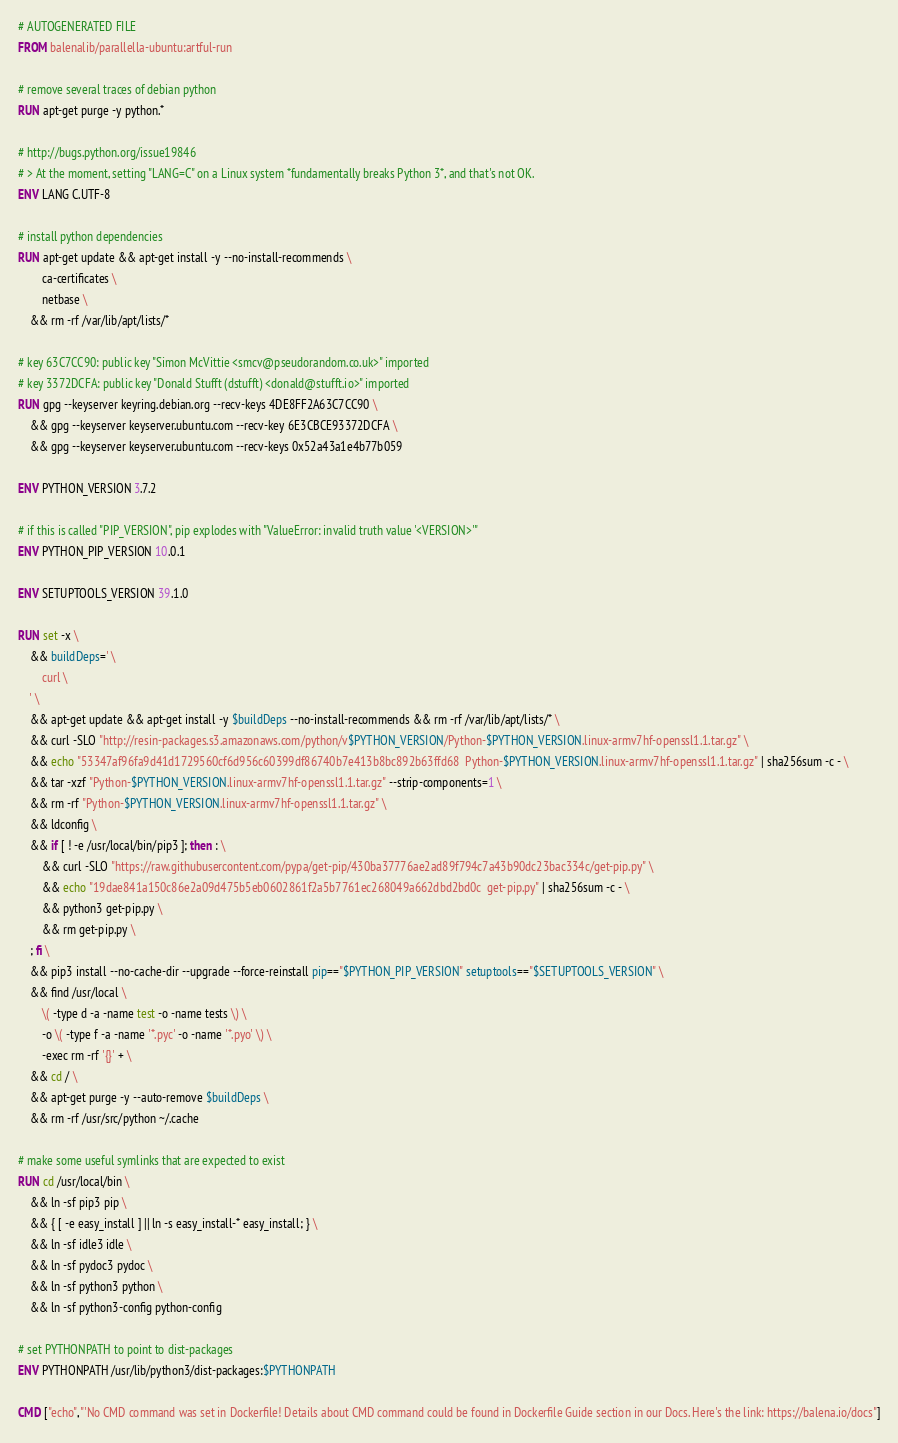<code> <loc_0><loc_0><loc_500><loc_500><_Dockerfile_># AUTOGENERATED FILE
FROM balenalib/parallella-ubuntu:artful-run

# remove several traces of debian python
RUN apt-get purge -y python.*

# http://bugs.python.org/issue19846
# > At the moment, setting "LANG=C" on a Linux system *fundamentally breaks Python 3*, and that's not OK.
ENV LANG C.UTF-8

# install python dependencies
RUN apt-get update && apt-get install -y --no-install-recommends \
		ca-certificates \
		netbase \
	&& rm -rf /var/lib/apt/lists/*

# key 63C7CC90: public key "Simon McVittie <smcv@pseudorandom.co.uk>" imported
# key 3372DCFA: public key "Donald Stufft (dstufft) <donald@stufft.io>" imported
RUN gpg --keyserver keyring.debian.org --recv-keys 4DE8FF2A63C7CC90 \
	&& gpg --keyserver keyserver.ubuntu.com --recv-key 6E3CBCE93372DCFA \
	&& gpg --keyserver keyserver.ubuntu.com --recv-keys 0x52a43a1e4b77b059

ENV PYTHON_VERSION 3.7.2

# if this is called "PIP_VERSION", pip explodes with "ValueError: invalid truth value '<VERSION>'"
ENV PYTHON_PIP_VERSION 10.0.1

ENV SETUPTOOLS_VERSION 39.1.0

RUN set -x \
	&& buildDeps=' \
		curl \
	' \
	&& apt-get update && apt-get install -y $buildDeps --no-install-recommends && rm -rf /var/lib/apt/lists/* \
	&& curl -SLO "http://resin-packages.s3.amazonaws.com/python/v$PYTHON_VERSION/Python-$PYTHON_VERSION.linux-armv7hf-openssl1.1.tar.gz" \
	&& echo "53347af96fa9d41d1729560cf6d956c60399df86740b7e413b8bc892b63ffd68  Python-$PYTHON_VERSION.linux-armv7hf-openssl1.1.tar.gz" | sha256sum -c - \
	&& tar -xzf "Python-$PYTHON_VERSION.linux-armv7hf-openssl1.1.tar.gz" --strip-components=1 \
	&& rm -rf "Python-$PYTHON_VERSION.linux-armv7hf-openssl1.1.tar.gz" \
	&& ldconfig \
	&& if [ ! -e /usr/local/bin/pip3 ]; then : \
		&& curl -SLO "https://raw.githubusercontent.com/pypa/get-pip/430ba37776ae2ad89f794c7a43b90dc23bac334c/get-pip.py" \
		&& echo "19dae841a150c86e2a09d475b5eb0602861f2a5b7761ec268049a662dbd2bd0c  get-pip.py" | sha256sum -c - \
		&& python3 get-pip.py \
		&& rm get-pip.py \
	; fi \
	&& pip3 install --no-cache-dir --upgrade --force-reinstall pip=="$PYTHON_PIP_VERSION" setuptools=="$SETUPTOOLS_VERSION" \
	&& find /usr/local \
		\( -type d -a -name test -o -name tests \) \
		-o \( -type f -a -name '*.pyc' -o -name '*.pyo' \) \
		-exec rm -rf '{}' + \
	&& cd / \
	&& apt-get purge -y --auto-remove $buildDeps \
	&& rm -rf /usr/src/python ~/.cache

# make some useful symlinks that are expected to exist
RUN cd /usr/local/bin \
	&& ln -sf pip3 pip \
	&& { [ -e easy_install ] || ln -s easy_install-* easy_install; } \
	&& ln -sf idle3 idle \
	&& ln -sf pydoc3 pydoc \
	&& ln -sf python3 python \
	&& ln -sf python3-config python-config

# set PYTHONPATH to point to dist-packages
ENV PYTHONPATH /usr/lib/python3/dist-packages:$PYTHONPATH

CMD ["echo","'No CMD command was set in Dockerfile! Details about CMD command could be found in Dockerfile Guide section in our Docs. Here's the link: https://balena.io/docs"]</code> 